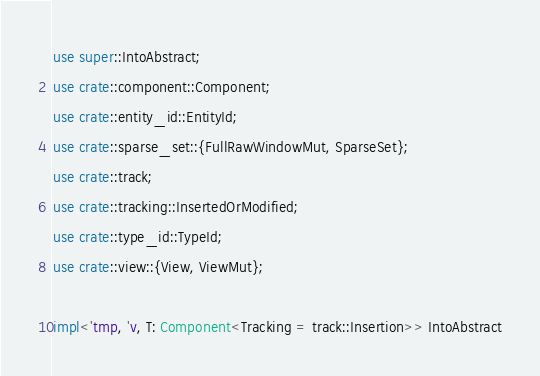Convert code to text. <code><loc_0><loc_0><loc_500><loc_500><_Rust_>use super::IntoAbstract;
use crate::component::Component;
use crate::entity_id::EntityId;
use crate::sparse_set::{FullRawWindowMut, SparseSet};
use crate::track;
use crate::tracking::InsertedOrModified;
use crate::type_id::TypeId;
use crate::view::{View, ViewMut};

impl<'tmp, 'v, T: Component<Tracking = track::Insertion>> IntoAbstract</code> 